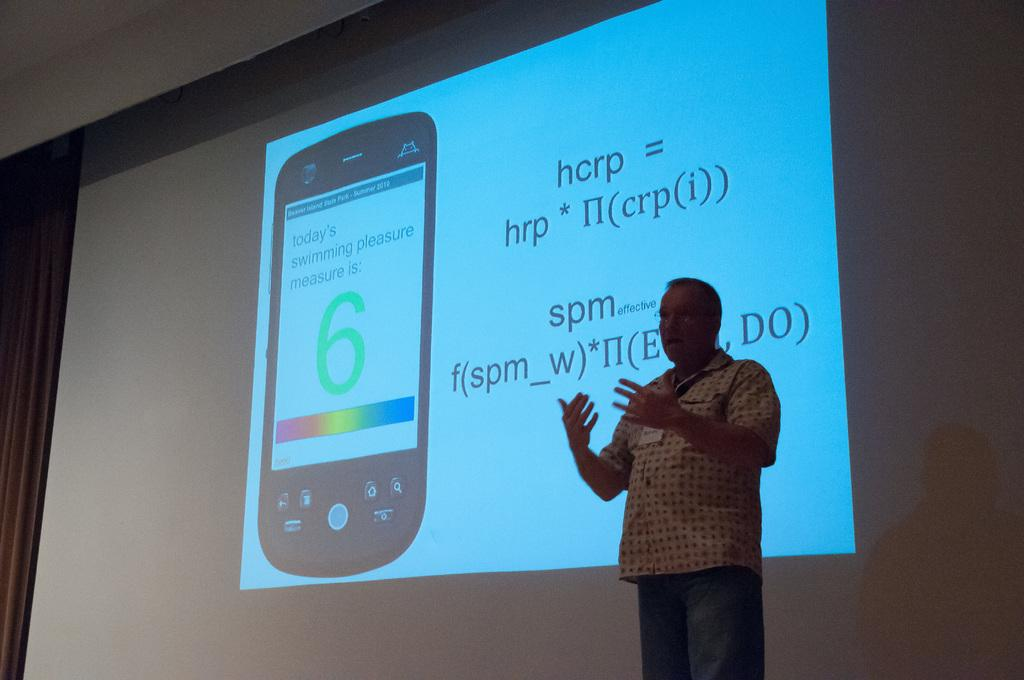<image>
Summarize the visual content of the image. man giving a lecture with projection of a formula and cellphone behind him that has message "today's swimming pleasure measure is: 6" 